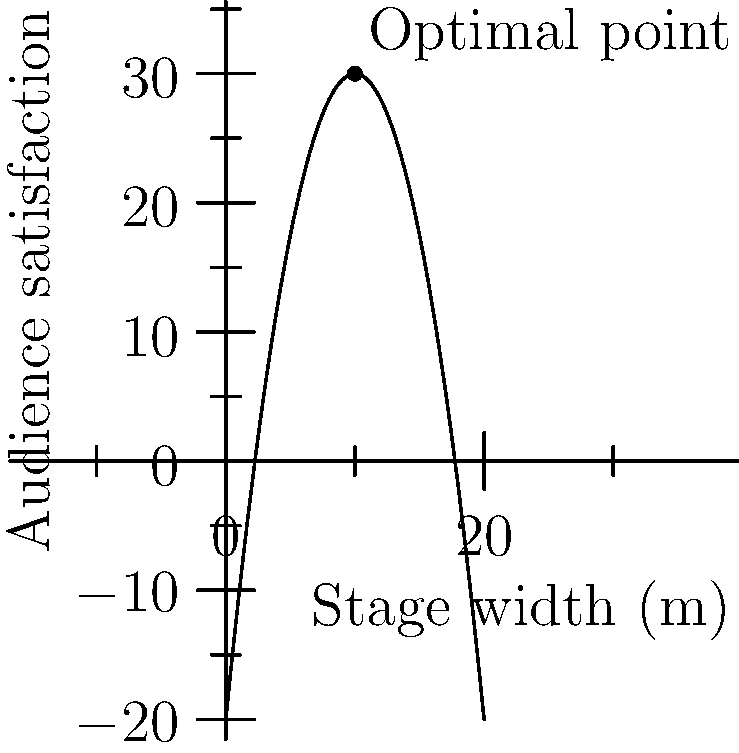For William Cloutier's upcoming concert, the event organizers want to optimize the stage setup. They've modeled the audience satisfaction (S) as a function of the stage width (w) in meters using the polynomial: $S(w) = -0.5w^2 + 10w - 20$. What is the optimal stage width to maximize audience satisfaction, and what is the maximum satisfaction level? To find the optimal stage width and maximum satisfaction level, we need to follow these steps:

1) The function $S(w) = -0.5w^2 + 10w - 20$ is a quadratic function, and its graph is a parabola.

2) The optimal point (maximum satisfaction) occurs at the vertex of this parabola.

3) For a quadratic function in the form $f(x) = ax^2 + bx + c$, the x-coordinate of the vertex is given by $x = -\frac{b}{2a}$.

4) In our case, $a = -0.5$, $b = 10$, and $c = -20$.

5) Optimal width = $-\frac{b}{2a} = -\frac{10}{2(-0.5)} = \frac{10}{1} = 10$ meters

6) To find the maximum satisfaction, we substitute this width back into the original function:

   $S(10) = -0.5(10)^2 + 10(10) - 20$
   $= -50 + 100 - 20$
   $= 30$

Therefore, the optimal stage width is 10 meters, and the maximum satisfaction level is 30 units.
Answer: 10 meters; 30 units 